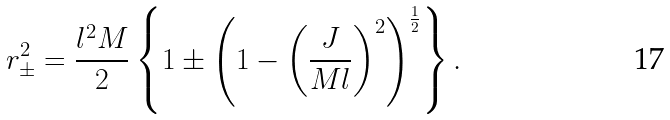Convert formula to latex. <formula><loc_0><loc_0><loc_500><loc_500>r _ { \pm } ^ { 2 } = \frac { l ^ { 2 } M } { 2 } \left \{ 1 \pm \left ( 1 - \left ( \frac { J } { M l } \right ) ^ { 2 } \right ) ^ { \frac { 1 } { 2 } } \right \} .</formula> 